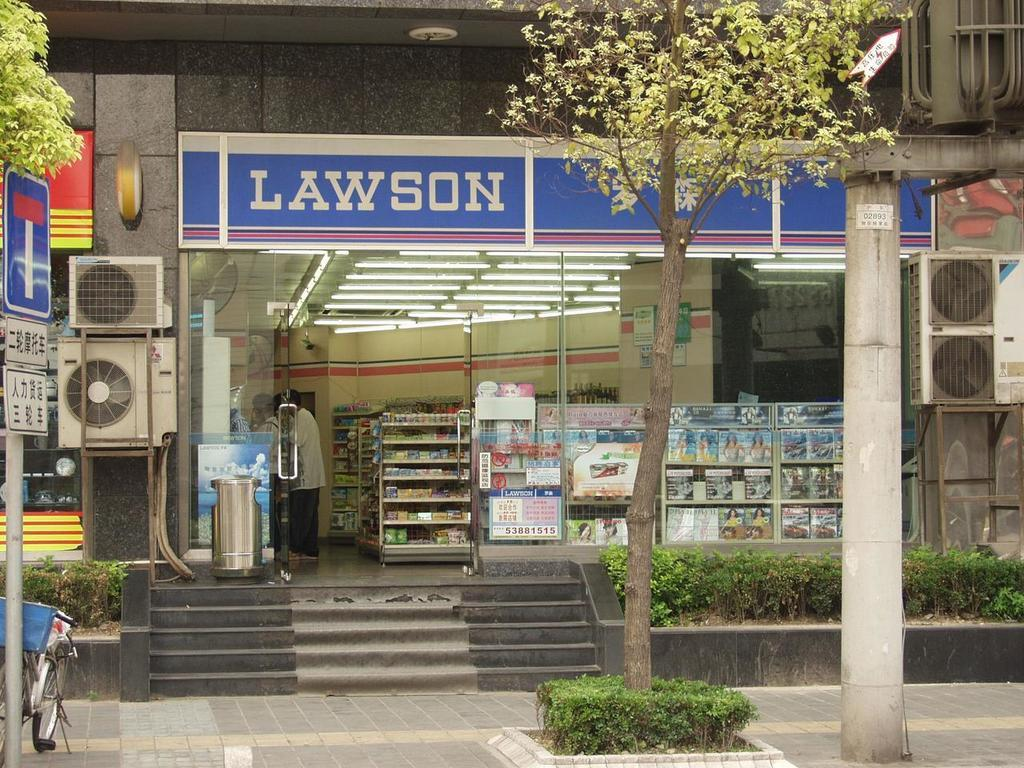<image>
Provide a brief description of the given image. A storefront with stairs leading up to it, named Lawson. 